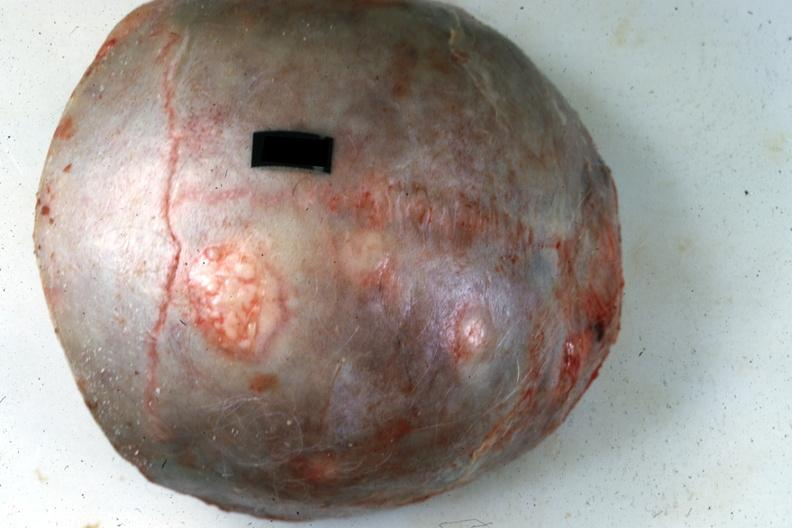s multiple myeloma present?
Answer the question using a single word or phrase. Yes 